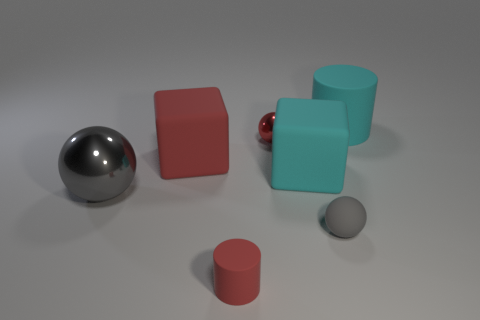How many matte objects have the same size as the cyan block?
Your answer should be very brief. 2. Does the cylinder in front of the big gray metal ball have the same size as the gray thing on the right side of the gray metal object?
Give a very brief answer. Yes. The large thing that is both on the left side of the red shiny object and right of the big ball has what shape?
Give a very brief answer. Cube. Are there any tiny matte balls that have the same color as the big metal sphere?
Make the answer very short. Yes. Is there a small gray matte thing?
Keep it short and to the point. Yes. There is a ball that is in front of the big metallic sphere; what color is it?
Offer a very short reply. Gray. There is a red block; does it have the same size as the cyan object that is to the left of the cyan cylinder?
Your answer should be very brief. Yes. There is a rubber object that is both behind the cyan rubber block and right of the red block; what size is it?
Your answer should be very brief. Large. Is there a tiny thing made of the same material as the cyan cylinder?
Offer a terse response. Yes. There is a gray shiny thing; what shape is it?
Your answer should be compact. Sphere. 